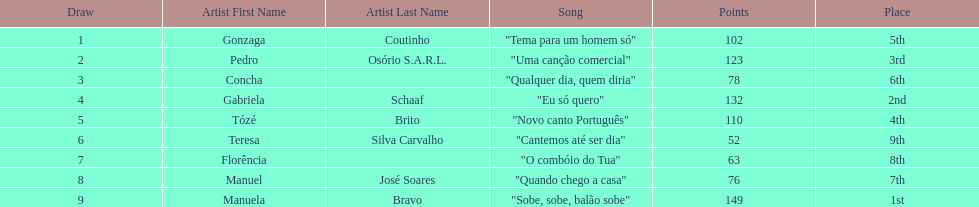Who scored the most points? Manuela Bravo. 